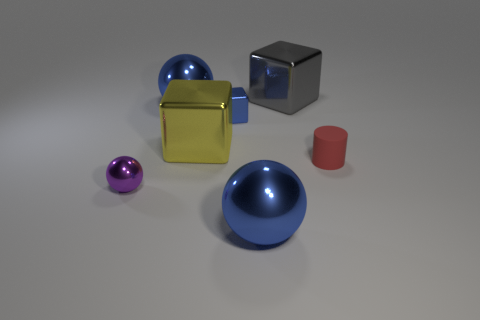Add 2 big blue shiny things. How many objects exist? 9 Subtract all spheres. How many objects are left? 4 Subtract all small yellow cylinders. Subtract all small red cylinders. How many objects are left? 6 Add 5 yellow blocks. How many yellow blocks are left? 6 Add 3 yellow metal things. How many yellow metal things exist? 4 Subtract 1 red cylinders. How many objects are left? 6 